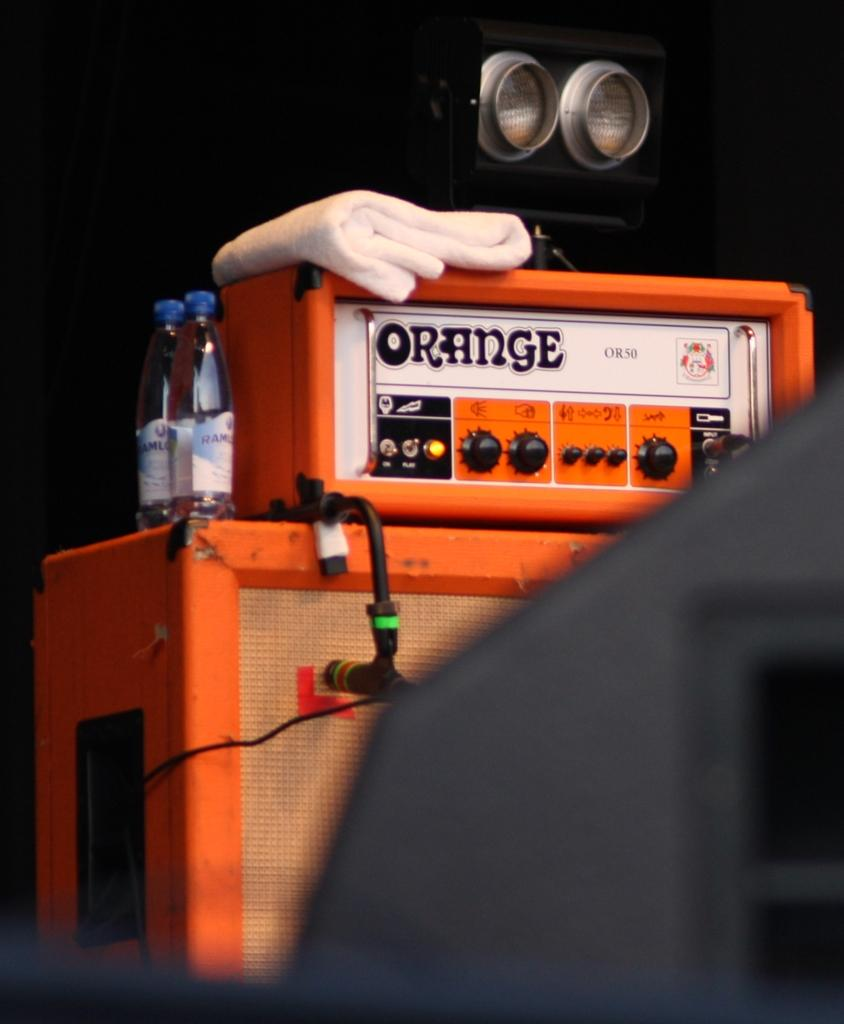<image>
Summarize the visual content of the image. A machine with Orange written on it is orange with gloves on top. 